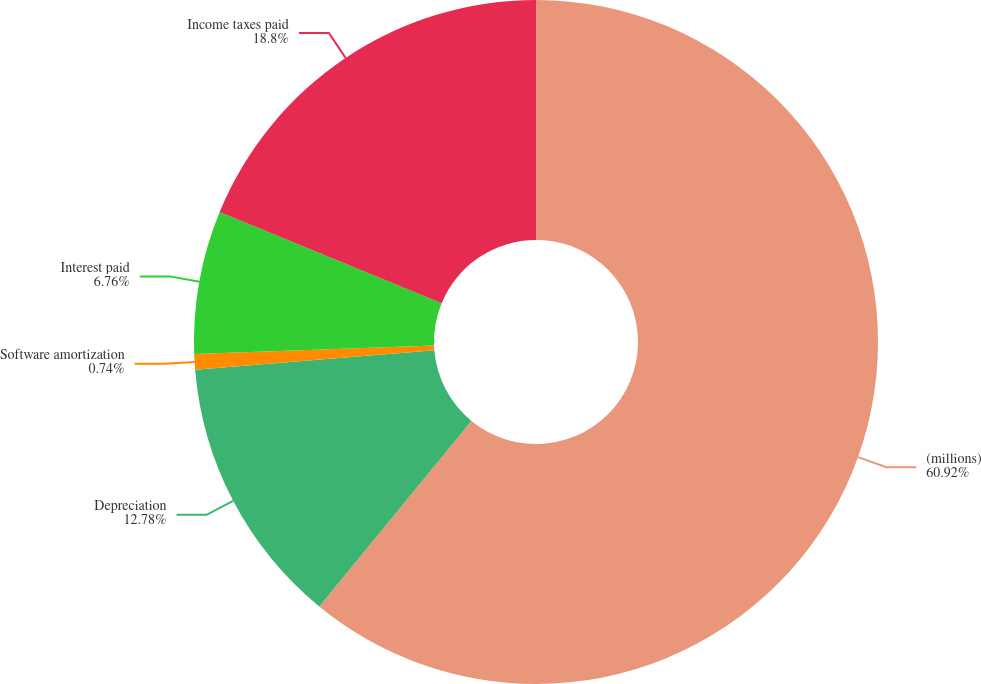Convert chart to OTSL. <chart><loc_0><loc_0><loc_500><loc_500><pie_chart><fcel>(millions)<fcel>Depreciation<fcel>Software amortization<fcel>Interest paid<fcel>Income taxes paid<nl><fcel>60.93%<fcel>12.78%<fcel>0.74%<fcel>6.76%<fcel>18.8%<nl></chart> 